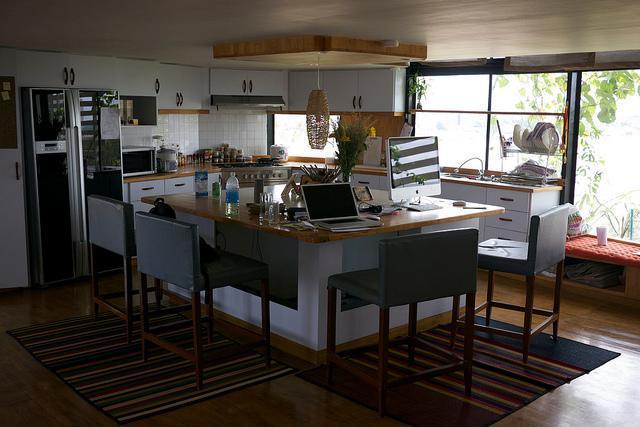How many people might live here?
Give a very brief answer. 4. How many chairs are in the image?
Give a very brief answer. 4. How many laptops are visible?
Give a very brief answer. 1. How many chairs are there?
Give a very brief answer. 4. 